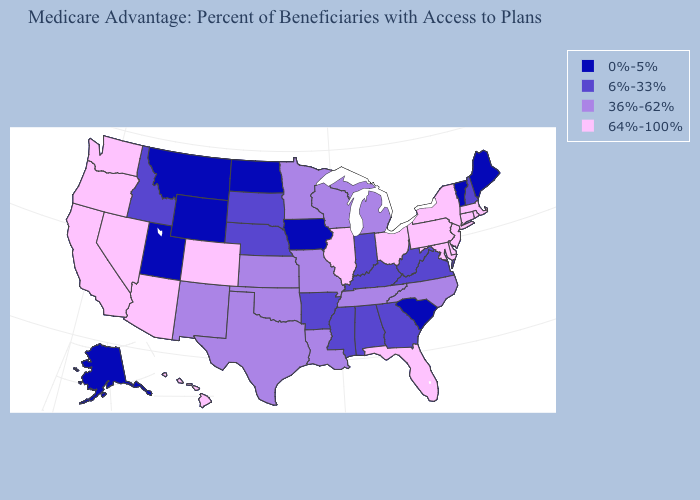Among the states that border California , which have the highest value?
Quick response, please. Arizona, Nevada, Oregon. Which states have the lowest value in the Northeast?
Short answer required. Maine, Vermont. Which states have the lowest value in the West?
Write a very short answer. Alaska, Montana, Utah, Wyoming. What is the value of South Carolina?
Write a very short answer. 0%-5%. What is the highest value in states that border Maryland?
Write a very short answer. 64%-100%. What is the highest value in the MidWest ?
Be succinct. 64%-100%. What is the value of Minnesota?
Concise answer only. 36%-62%. Name the states that have a value in the range 6%-33%?
Concise answer only. Alabama, Arkansas, Georgia, Idaho, Indiana, Kentucky, Mississippi, Nebraska, New Hampshire, South Dakota, Virginia, West Virginia. Does the first symbol in the legend represent the smallest category?
Be succinct. Yes. Name the states that have a value in the range 0%-5%?
Write a very short answer. Alaska, Iowa, Maine, Montana, North Dakota, South Carolina, Utah, Vermont, Wyoming. Which states have the lowest value in the USA?
Write a very short answer. Alaska, Iowa, Maine, Montana, North Dakota, South Carolina, Utah, Vermont, Wyoming. What is the highest value in states that border New Mexico?
Short answer required. 64%-100%. Does the first symbol in the legend represent the smallest category?
Answer briefly. Yes. What is the lowest value in the USA?
Answer briefly. 0%-5%. Does the map have missing data?
Short answer required. No. 